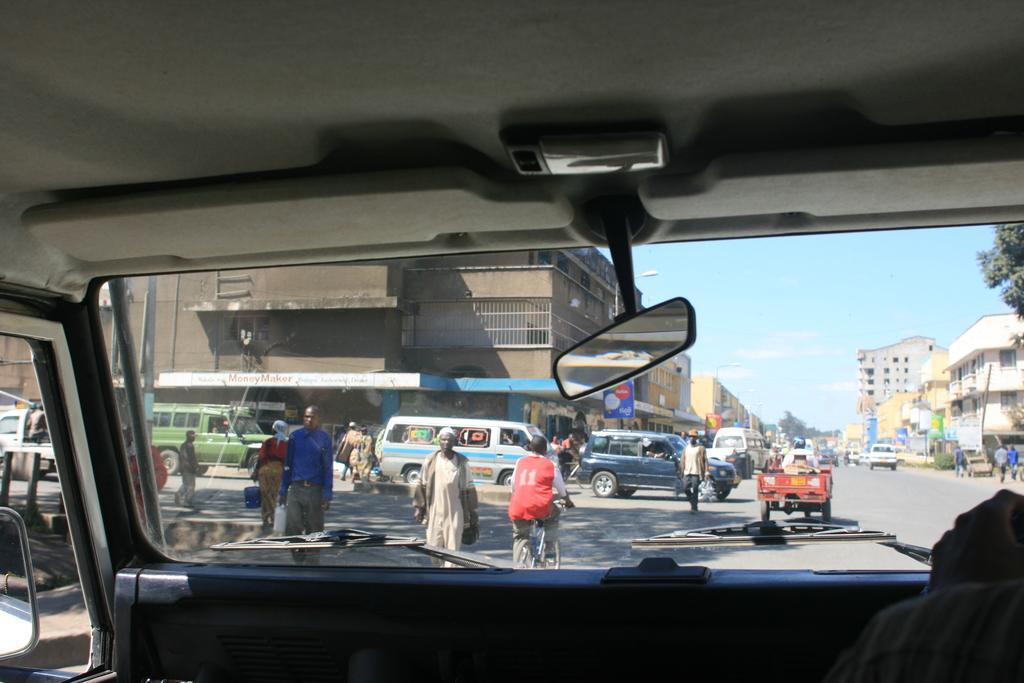Describe this image in one or two sentences. This is clicked from inside a car, in the front there are many vehicles and people going on the road with buildings on either side and above its sky with clouds. 